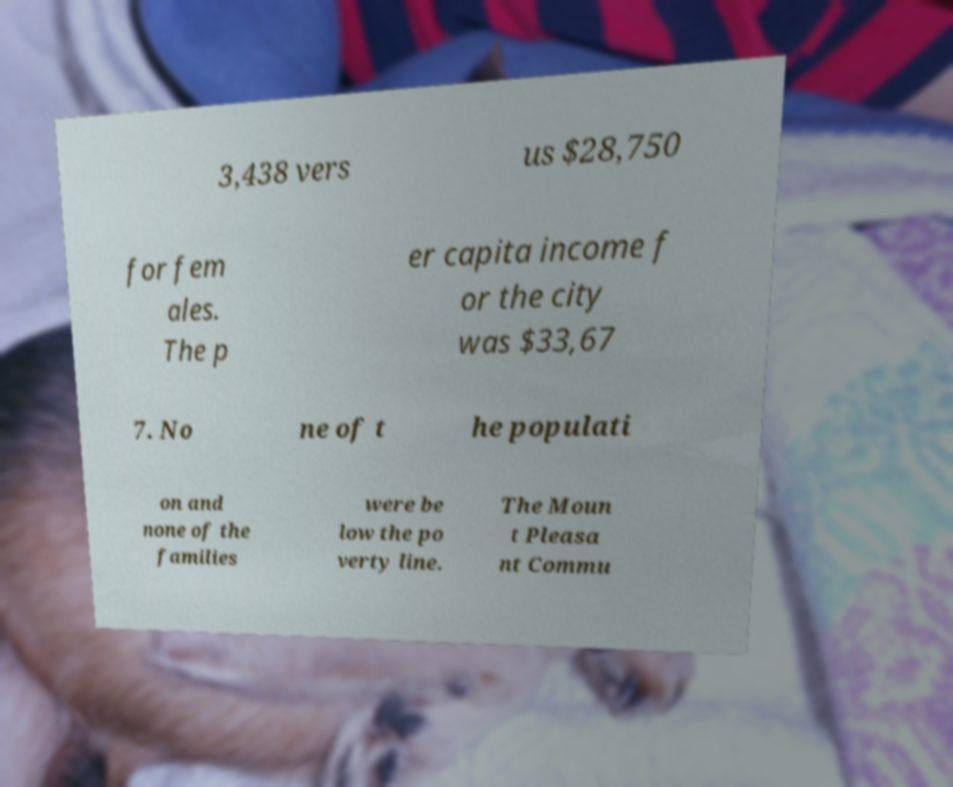Could you assist in decoding the text presented in this image and type it out clearly? 3,438 vers us $28,750 for fem ales. The p er capita income f or the city was $33,67 7. No ne of t he populati on and none of the families were be low the po verty line. The Moun t Pleasa nt Commu 